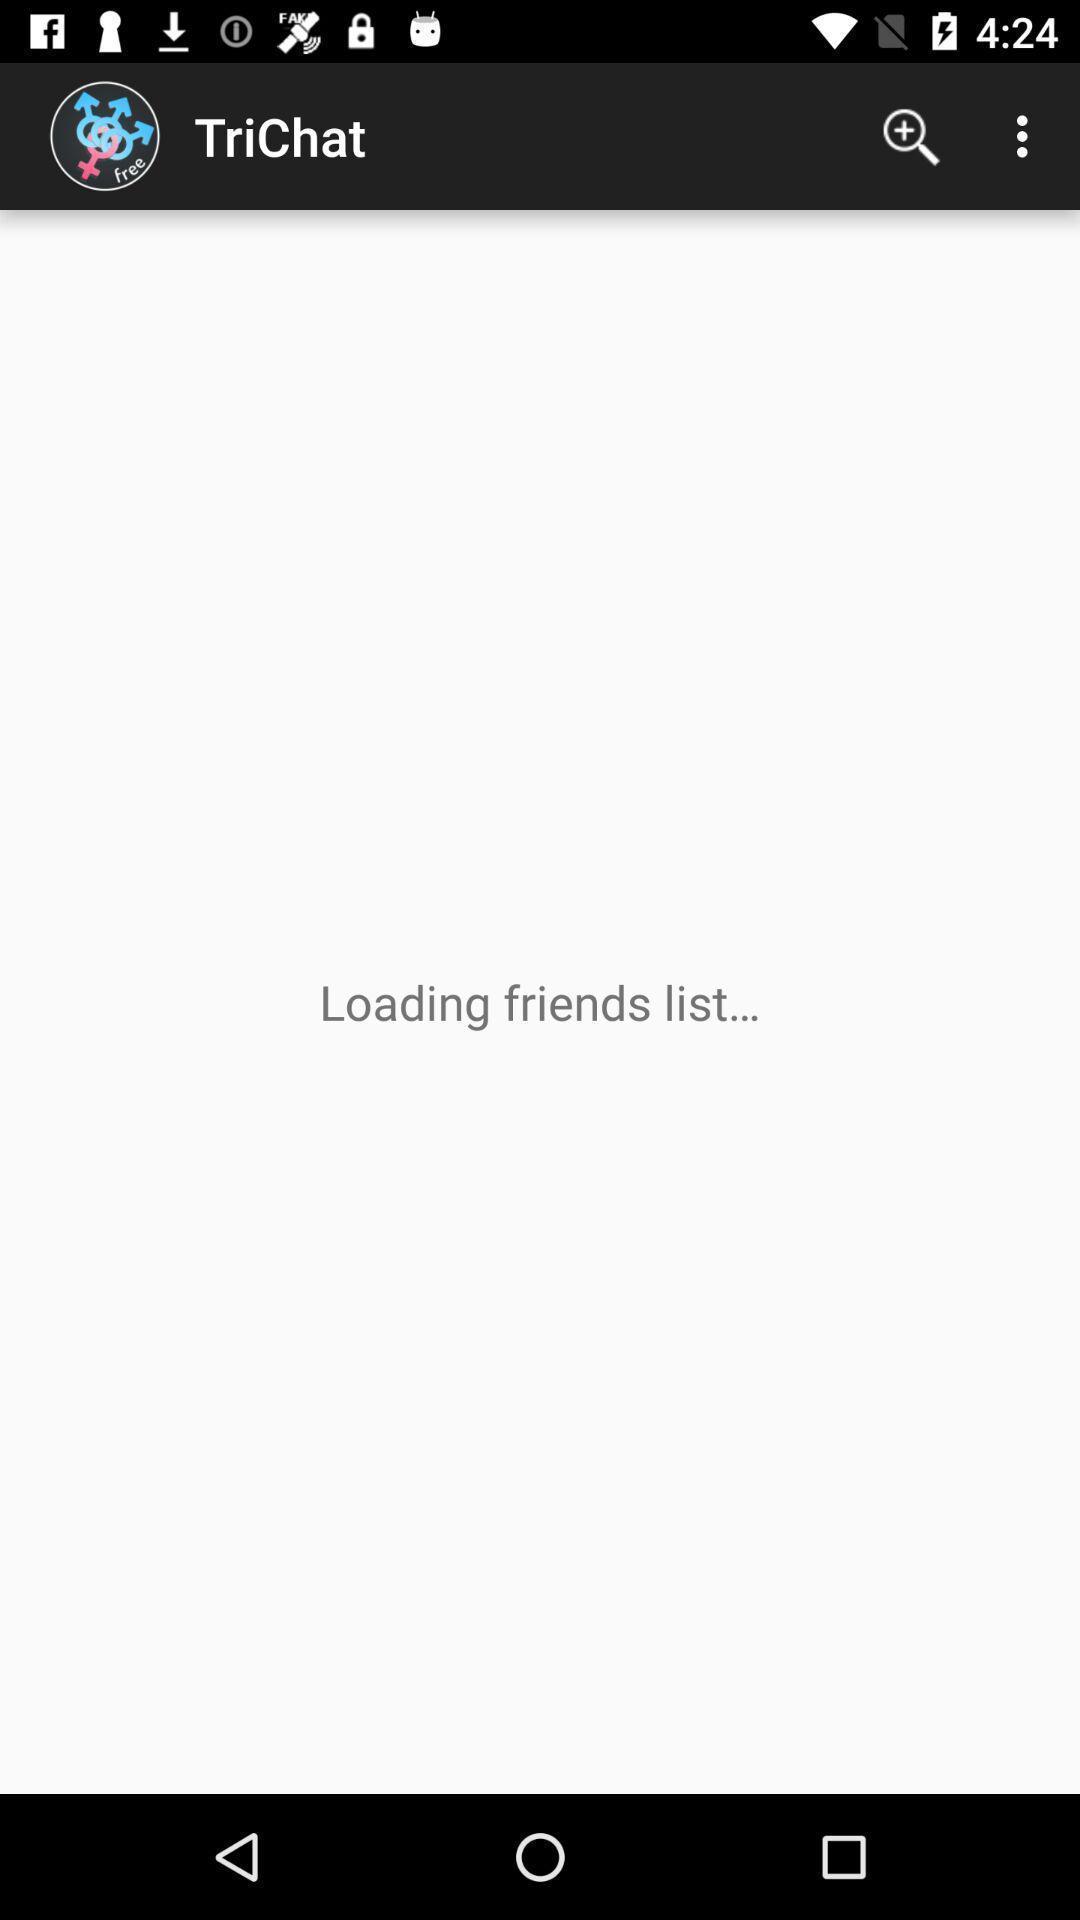Tell me about the visual elements in this screen capture. Screen displaying the page of a chat app. 